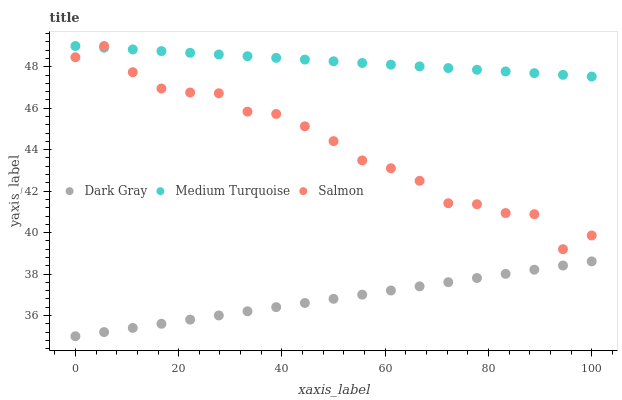Does Dark Gray have the minimum area under the curve?
Answer yes or no. Yes. Does Medium Turquoise have the maximum area under the curve?
Answer yes or no. Yes. Does Salmon have the minimum area under the curve?
Answer yes or no. No. Does Salmon have the maximum area under the curve?
Answer yes or no. No. Is Medium Turquoise the smoothest?
Answer yes or no. Yes. Is Salmon the roughest?
Answer yes or no. Yes. Is Salmon the smoothest?
Answer yes or no. No. Is Medium Turquoise the roughest?
Answer yes or no. No. Does Dark Gray have the lowest value?
Answer yes or no. Yes. Does Salmon have the lowest value?
Answer yes or no. No. Does Medium Turquoise have the highest value?
Answer yes or no. Yes. Is Dark Gray less than Medium Turquoise?
Answer yes or no. Yes. Is Medium Turquoise greater than Dark Gray?
Answer yes or no. Yes. Does Salmon intersect Medium Turquoise?
Answer yes or no. Yes. Is Salmon less than Medium Turquoise?
Answer yes or no. No. Is Salmon greater than Medium Turquoise?
Answer yes or no. No. Does Dark Gray intersect Medium Turquoise?
Answer yes or no. No. 